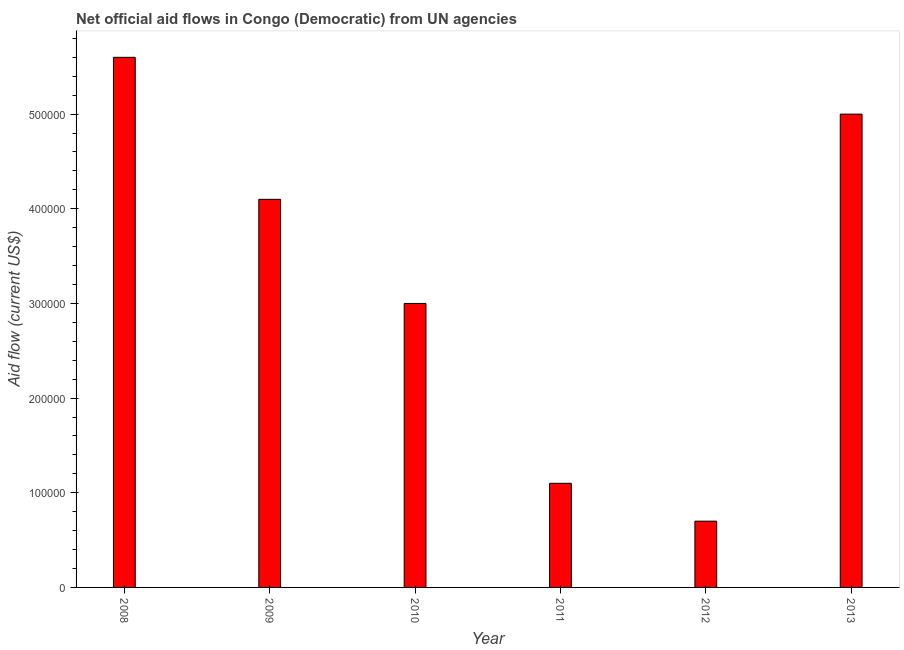Does the graph contain grids?
Offer a very short reply. No. What is the title of the graph?
Offer a very short reply. Net official aid flows in Congo (Democratic) from UN agencies. Across all years, what is the maximum net official flows from un agencies?
Offer a very short reply. 5.60e+05. Across all years, what is the minimum net official flows from un agencies?
Your answer should be very brief. 7.00e+04. What is the sum of the net official flows from un agencies?
Ensure brevity in your answer.  1.95e+06. What is the difference between the net official flows from un agencies in 2008 and 2012?
Make the answer very short. 4.90e+05. What is the average net official flows from un agencies per year?
Give a very brief answer. 3.25e+05. What is the median net official flows from un agencies?
Your response must be concise. 3.55e+05. What is the ratio of the net official flows from un agencies in 2009 to that in 2013?
Ensure brevity in your answer.  0.82. Is the net official flows from un agencies in 2009 less than that in 2012?
Make the answer very short. No. Is the difference between the net official flows from un agencies in 2011 and 2013 greater than the difference between any two years?
Your response must be concise. No. In how many years, is the net official flows from un agencies greater than the average net official flows from un agencies taken over all years?
Ensure brevity in your answer.  3. How many years are there in the graph?
Your answer should be very brief. 6. What is the Aid flow (current US$) of 2008?
Provide a succinct answer. 5.60e+05. What is the Aid flow (current US$) in 2010?
Offer a very short reply. 3.00e+05. What is the Aid flow (current US$) in 2013?
Your answer should be compact. 5.00e+05. What is the difference between the Aid flow (current US$) in 2008 and 2010?
Your answer should be compact. 2.60e+05. What is the difference between the Aid flow (current US$) in 2008 and 2012?
Your answer should be compact. 4.90e+05. What is the difference between the Aid flow (current US$) in 2008 and 2013?
Provide a short and direct response. 6.00e+04. What is the difference between the Aid flow (current US$) in 2009 and 2012?
Your response must be concise. 3.40e+05. What is the difference between the Aid flow (current US$) in 2010 and 2013?
Ensure brevity in your answer.  -2.00e+05. What is the difference between the Aid flow (current US$) in 2011 and 2013?
Offer a terse response. -3.90e+05. What is the difference between the Aid flow (current US$) in 2012 and 2013?
Make the answer very short. -4.30e+05. What is the ratio of the Aid flow (current US$) in 2008 to that in 2009?
Make the answer very short. 1.37. What is the ratio of the Aid flow (current US$) in 2008 to that in 2010?
Provide a succinct answer. 1.87. What is the ratio of the Aid flow (current US$) in 2008 to that in 2011?
Provide a succinct answer. 5.09. What is the ratio of the Aid flow (current US$) in 2008 to that in 2013?
Make the answer very short. 1.12. What is the ratio of the Aid flow (current US$) in 2009 to that in 2010?
Provide a succinct answer. 1.37. What is the ratio of the Aid flow (current US$) in 2009 to that in 2011?
Ensure brevity in your answer.  3.73. What is the ratio of the Aid flow (current US$) in 2009 to that in 2012?
Your response must be concise. 5.86. What is the ratio of the Aid flow (current US$) in 2009 to that in 2013?
Keep it short and to the point. 0.82. What is the ratio of the Aid flow (current US$) in 2010 to that in 2011?
Give a very brief answer. 2.73. What is the ratio of the Aid flow (current US$) in 2010 to that in 2012?
Offer a terse response. 4.29. What is the ratio of the Aid flow (current US$) in 2010 to that in 2013?
Give a very brief answer. 0.6. What is the ratio of the Aid flow (current US$) in 2011 to that in 2012?
Your answer should be very brief. 1.57. What is the ratio of the Aid flow (current US$) in 2011 to that in 2013?
Offer a very short reply. 0.22. What is the ratio of the Aid flow (current US$) in 2012 to that in 2013?
Your response must be concise. 0.14. 